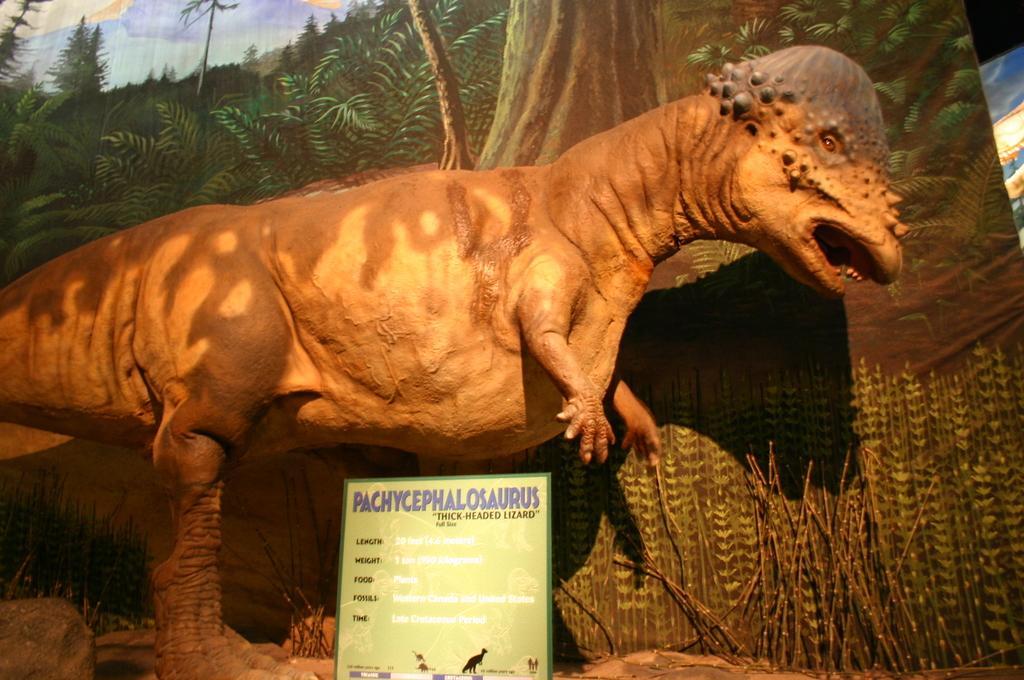How would you summarize this image in a sentence or two? There is a sculpture of a dinosaur and there is a board in front of it. There is a curtain at the back which has a painting of trees. There is a rock on the left. 